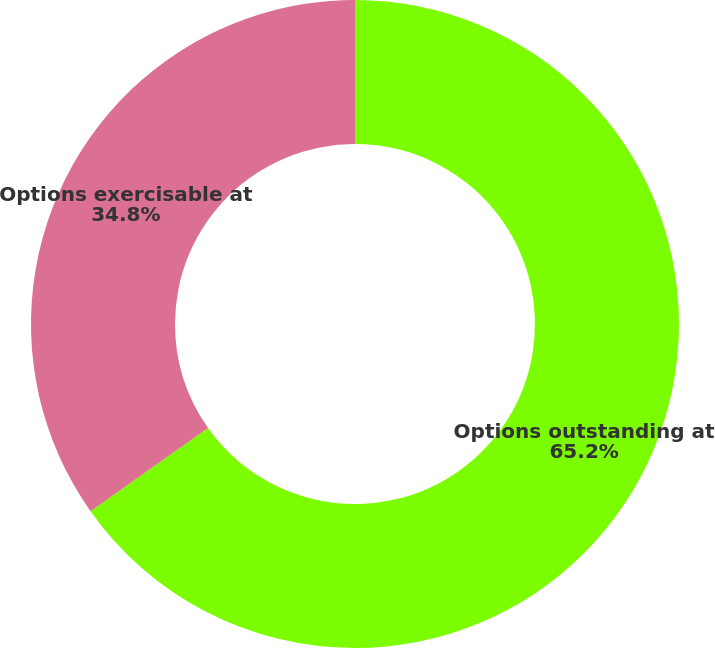Convert chart. <chart><loc_0><loc_0><loc_500><loc_500><pie_chart><fcel>Options outstanding at<fcel>Options exercisable at<nl><fcel>65.2%<fcel>34.8%<nl></chart> 